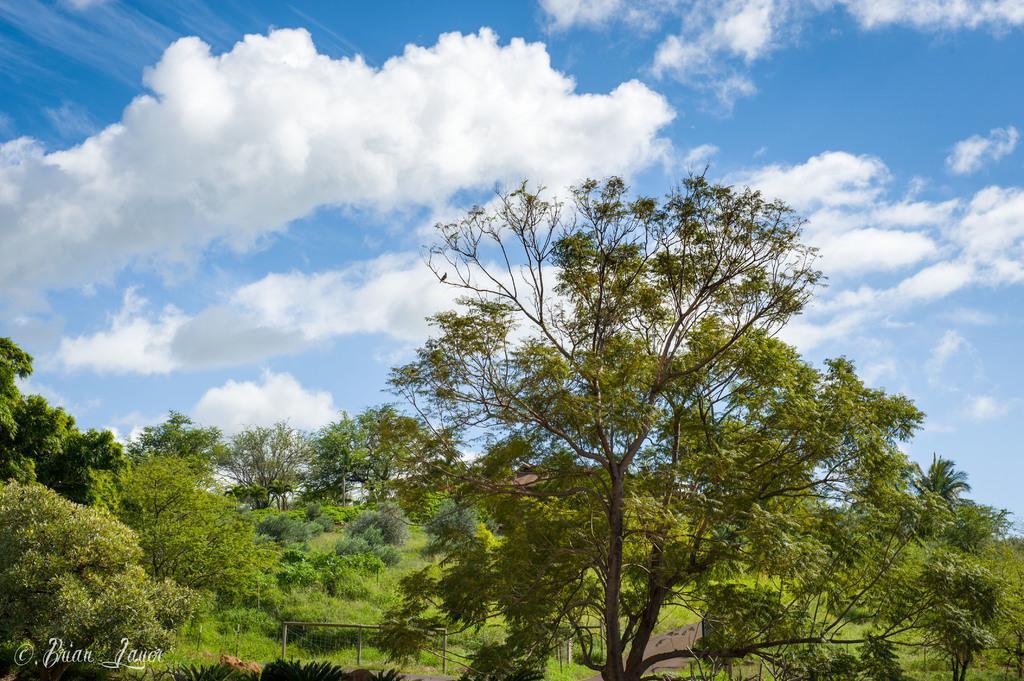Describe this image in one or two sentences. In this image there are plants and trees. At the top there is the sky. In the bottom left there is text on the image. 